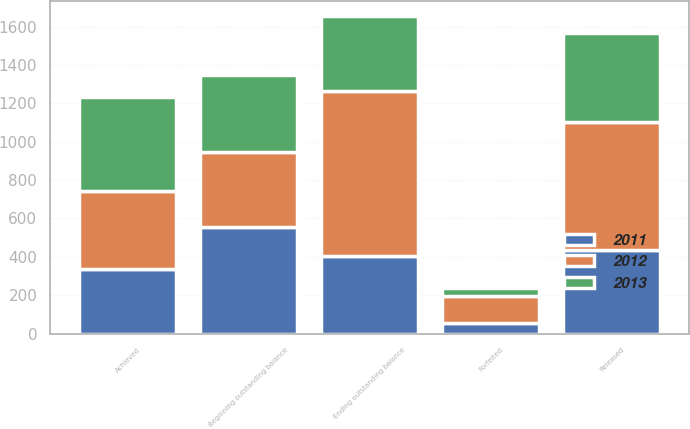<chart> <loc_0><loc_0><loc_500><loc_500><stacked_bar_chart><ecel><fcel>Beginning outstanding balance<fcel>Achieved<fcel>Released<fcel>Forfeited<fcel>Ending outstanding balance<nl><fcel>2012<fcel>388<fcel>405<fcel>665<fcel>141<fcel>861<nl><fcel>2013<fcel>405<fcel>492<fcel>464<fcel>45<fcel>388<nl><fcel>2011<fcel>557<fcel>337<fcel>436<fcel>53<fcel>405<nl></chart> 